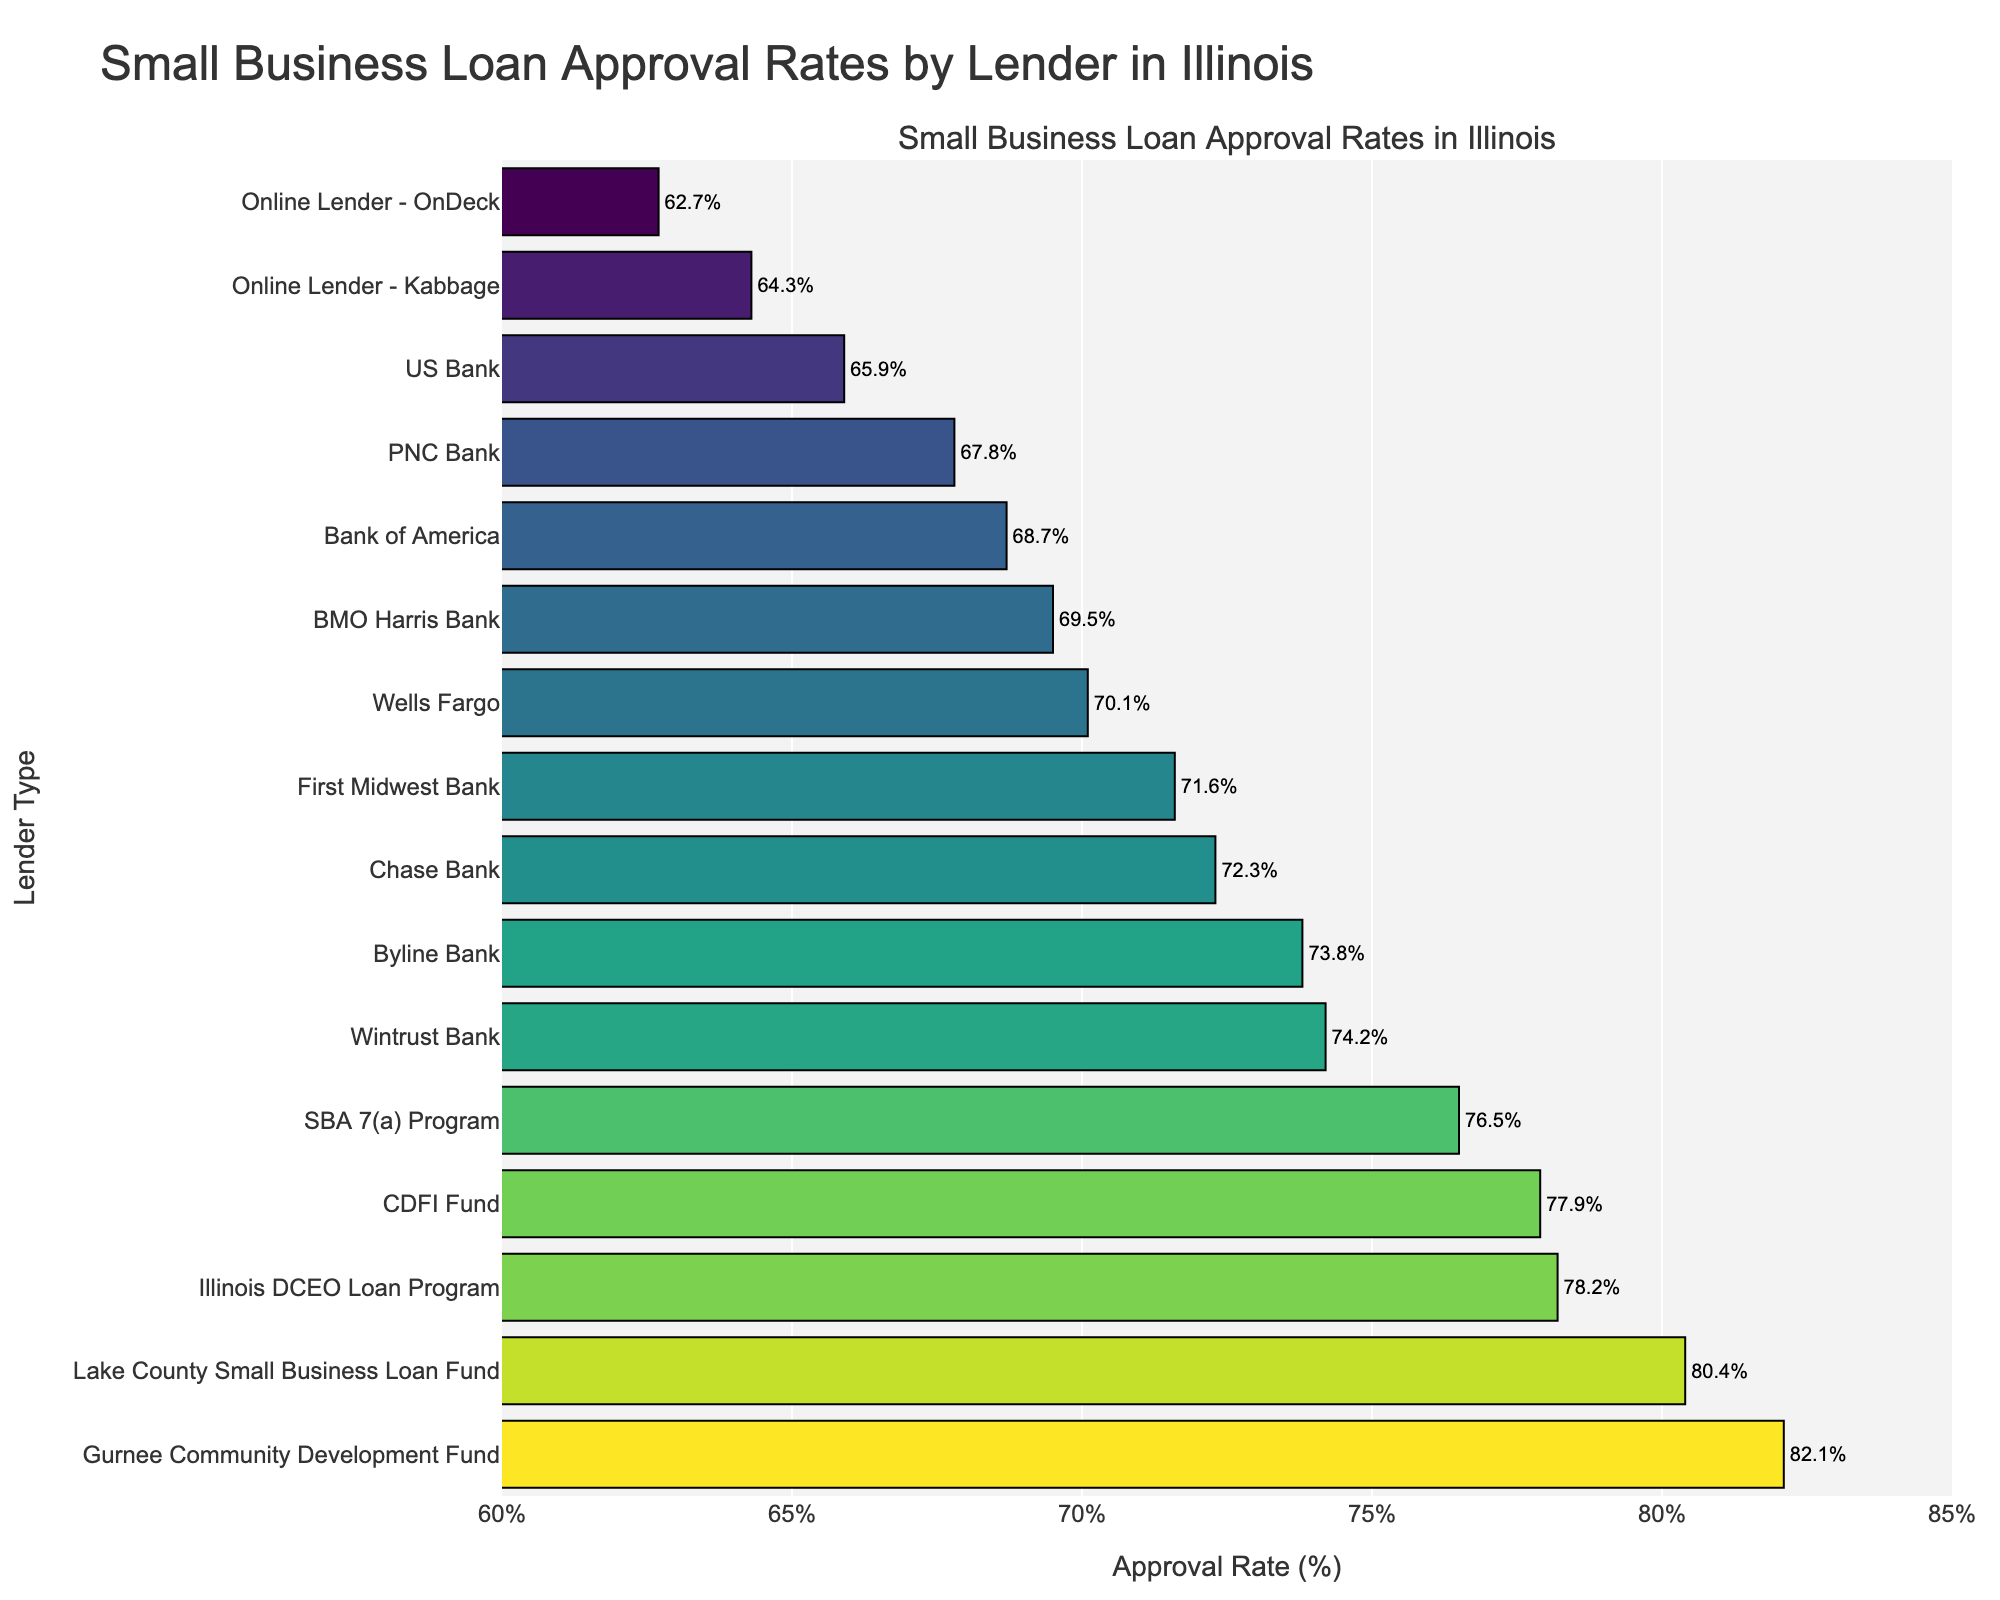Which lender has the highest approval rate? The Gurnee Community Development Fund has the highest approval rate at 82.1%, as indicated by the tallest bar reaching the highest point on the x-axis.
Answer: Gurnee Community Development Fund Which is the lowest approval rate, and which lender does it correspond to? The lowest approval rate is 62.7%, which corresponds to the Online Lender - OnDeck. You can see this by locating the shortest bar on the figure.
Answer: Online Lender - OnDeck How many lenders have an approval rate of 75% or higher? Lenders with approval rates of 75% or higher are the SBA 7(a) Program, Illinois DCEO Loan Program, Lake County Small Business Loan Fund, Gurnee Community Development Fund, and CDFI Fund. Count the number of bars starting from 75% onwards on the x-axis.
Answer: 5 What's the difference between the highest and the lowest approval rates? The highest approval rate is 82.1% (Gurnee Community Development Fund), and the lowest approval rate is 62.7% (Online Lender - OnDeck). Subtract these values: 82.1% - 62.7% = 19.4%.
Answer: 19.4% What is the average approval rate of the three online lenders? There are two online lenders listed: Online Lender - Kabbage and Online Lender - OnDeck. Their approval rates are 64.3% and 62.7%. Add these rates: 64.3% + 62.7% = 127%. Divide by the number of lenders: 127% / 2 = 63.5%.
Answer: 63.5% Which traditional bank has the highest approval rate? The traditional bank with the highest approval rate is Wintrust Bank at 74.2%. This can be determined by identifying the highest bar among the banks categorized as traditional banks.
Answer: Wintrust Bank Do any two lenders have the same approval rate? No, all lenders listed have unique approval rates. This can be observed by looking at each bar and noting that no two bars reach the exact same x-axis value.
Answer: No Compare the approval rates of Bank of America and Wells Fargo. Which is higher and by how much? Bank of America's approval rate is 68.7%, and Wells Fargo's approval rate is 70.1%. Wells Fargo's approval rate is 70.1% - 68.7% = 1.4% higher than Bank of America's.
Answer: Wells Fargo by 1.4% What is the median approval rate of all listed lenders? To find the median, list all approval rates in ascending order: 62.7, 64.3, 65.9, 67.8, 68.7, 69.5, 70.1, 71.6, 72.3, 73.8, 74.2, 76.5, 77.9, 78.2, 80.4, 82.1. There are 16 values, so the median is the average of the 8th and 9th values: (71.6 + 72.3) / 2 = 71.95%.
Answer: 71.95% 